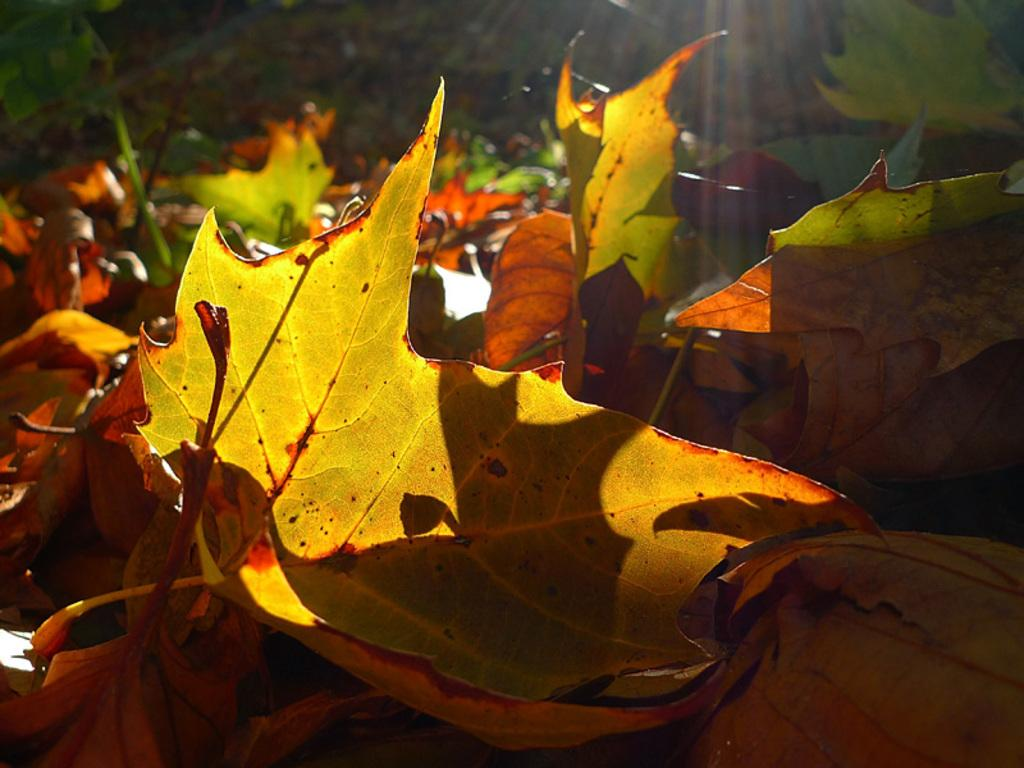What type of natural elements can be seen in the image? There are dried leaves in the image. Can you describe the background of the image? The background of the image is blurred. What type of spot can be seen on the dried leaves in the image? There are no spots visible on the dried leaves in the image. Can you tell me who made the request for the image to be taken? There is no information about who made the request for the image to be taken, as the focus is on the content of the image itself. 